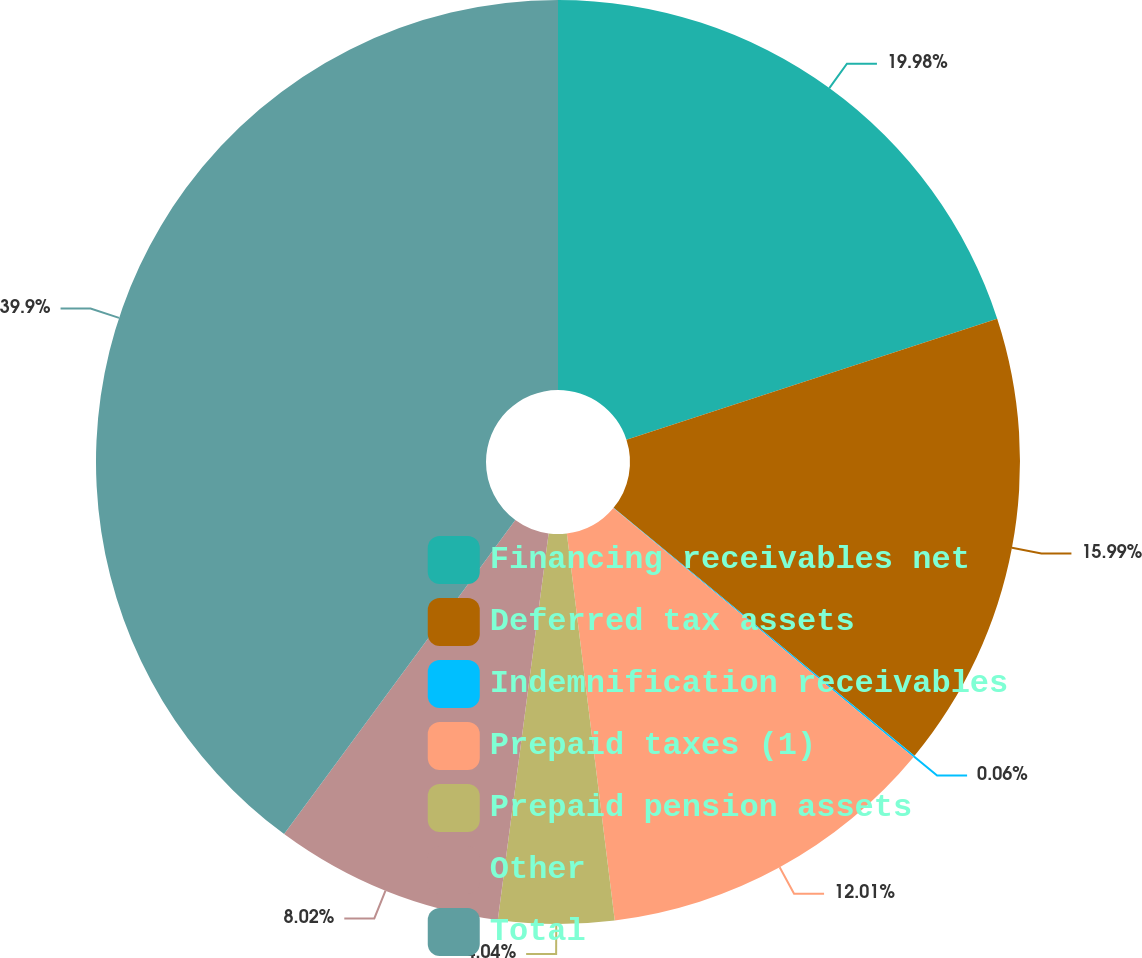Convert chart to OTSL. <chart><loc_0><loc_0><loc_500><loc_500><pie_chart><fcel>Financing receivables net<fcel>Deferred tax assets<fcel>Indemnification receivables<fcel>Prepaid taxes (1)<fcel>Prepaid pension assets<fcel>Other<fcel>Total<nl><fcel>19.98%<fcel>15.99%<fcel>0.06%<fcel>12.01%<fcel>4.04%<fcel>8.02%<fcel>39.9%<nl></chart> 